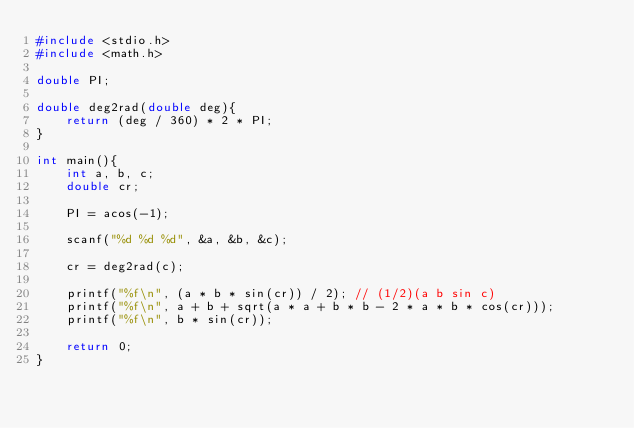<code> <loc_0><loc_0><loc_500><loc_500><_C_>#include <stdio.h>
#include <math.h>

double PI;

double deg2rad(double deg){
    return (deg / 360) * 2 * PI;
}

int main(){
    int a, b, c;
    double cr;
    
    PI = acos(-1);
    
    scanf("%d %d %d", &a, &b, &c);
    
    cr = deg2rad(c);
    
    printf("%f\n", (a * b * sin(cr)) / 2); // (1/2)(a b sin c)
    printf("%f\n", a + b + sqrt(a * a + b * b - 2 * a * b * cos(cr)));
    printf("%f\n", b * sin(cr));
    
    return 0;
}</code> 